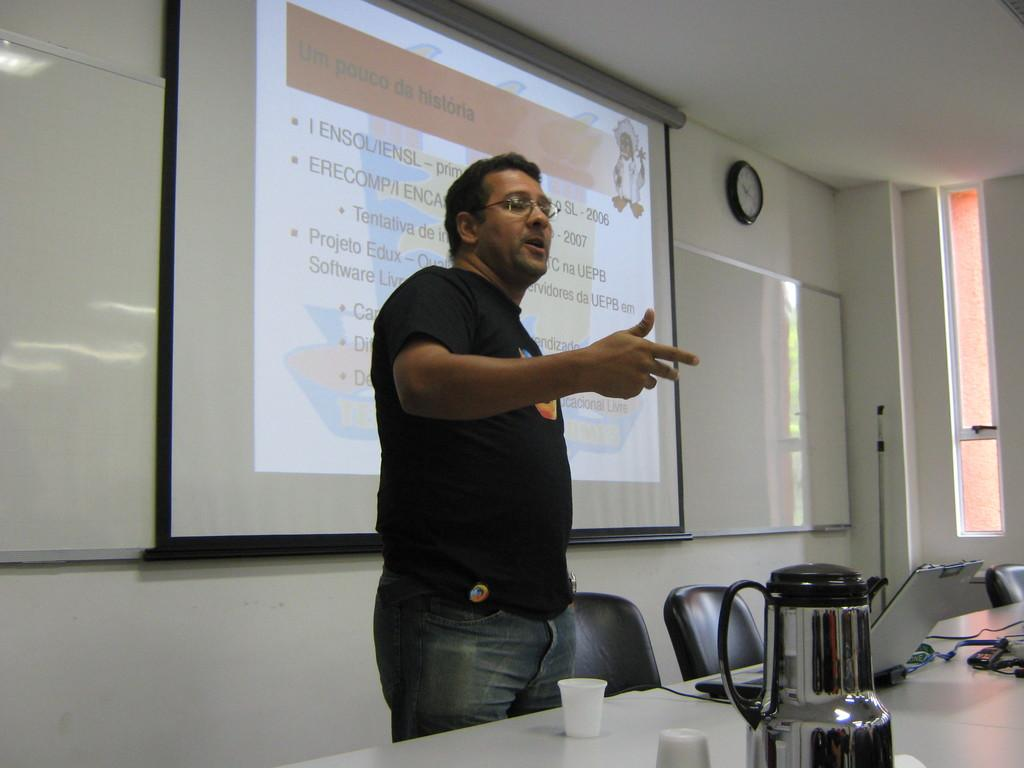Provide a one-sentence caption for the provided image. A man stands in front of a room with a projected slide labeled Un Pouco da historia. 